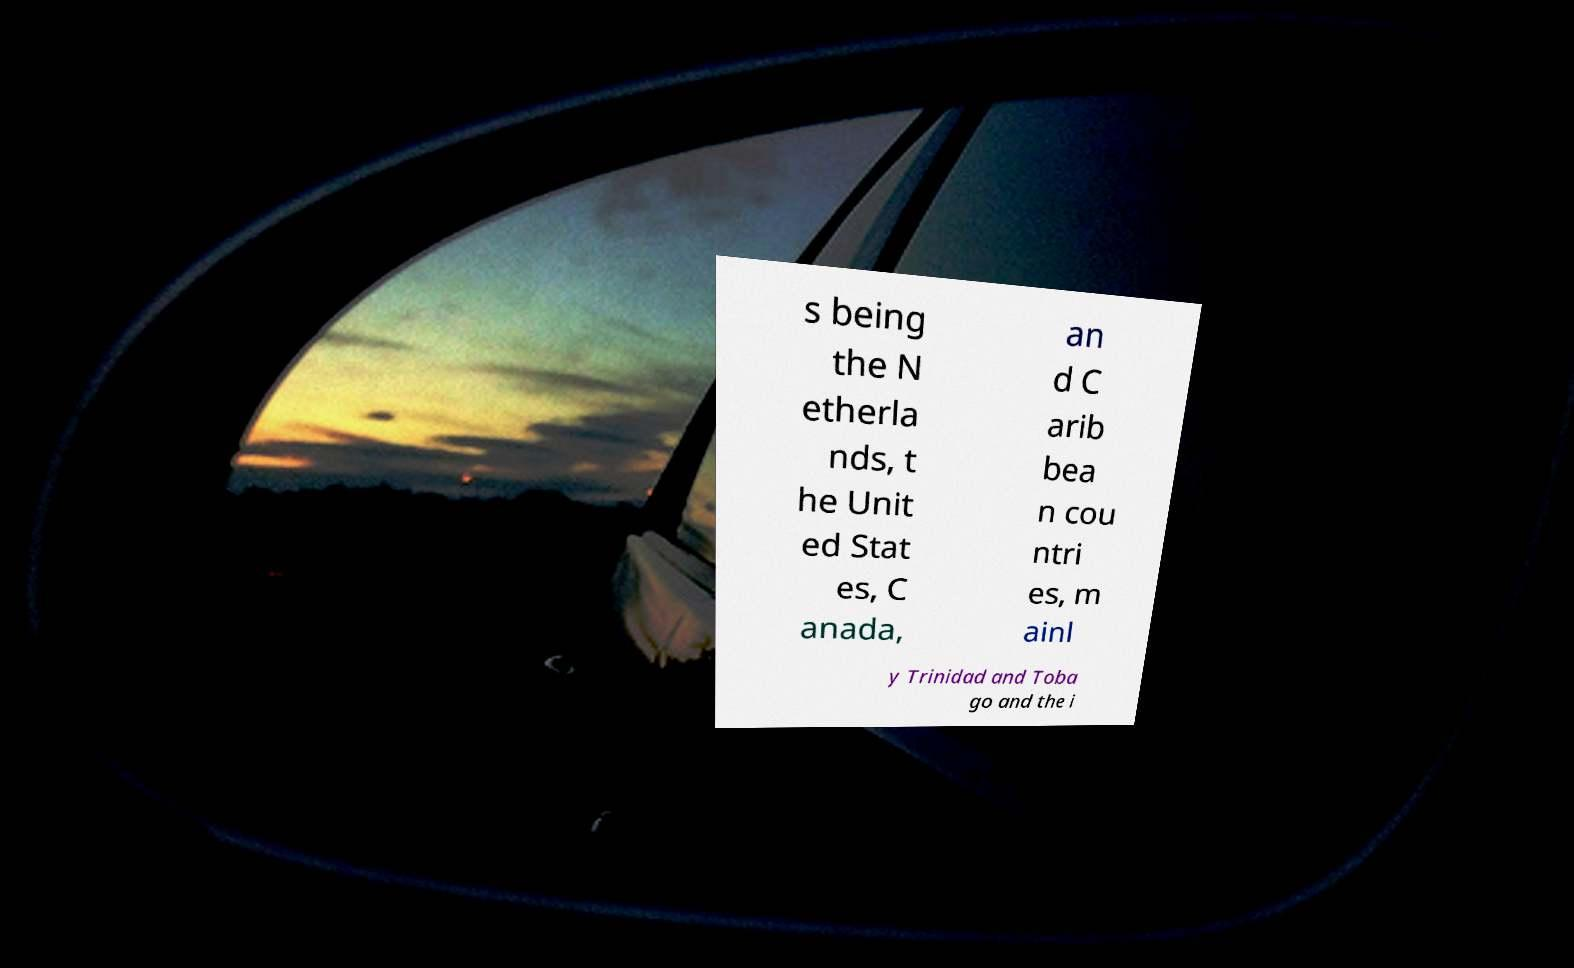Please read and relay the text visible in this image. What does it say? s being the N etherla nds, t he Unit ed Stat es, C anada, an d C arib bea n cou ntri es, m ainl y Trinidad and Toba go and the i 